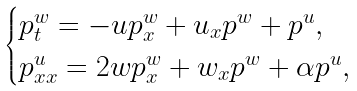<formula> <loc_0><loc_0><loc_500><loc_500>\begin{cases} p ^ { w } _ { t } = - u p ^ { w } _ { x } + u _ { x } p ^ { w } + p ^ { u } , \\ p ^ { u } _ { x x } = 2 w p ^ { w } _ { x } + w _ { x } p ^ { w } + \alpha p ^ { u } , \end{cases}</formula> 